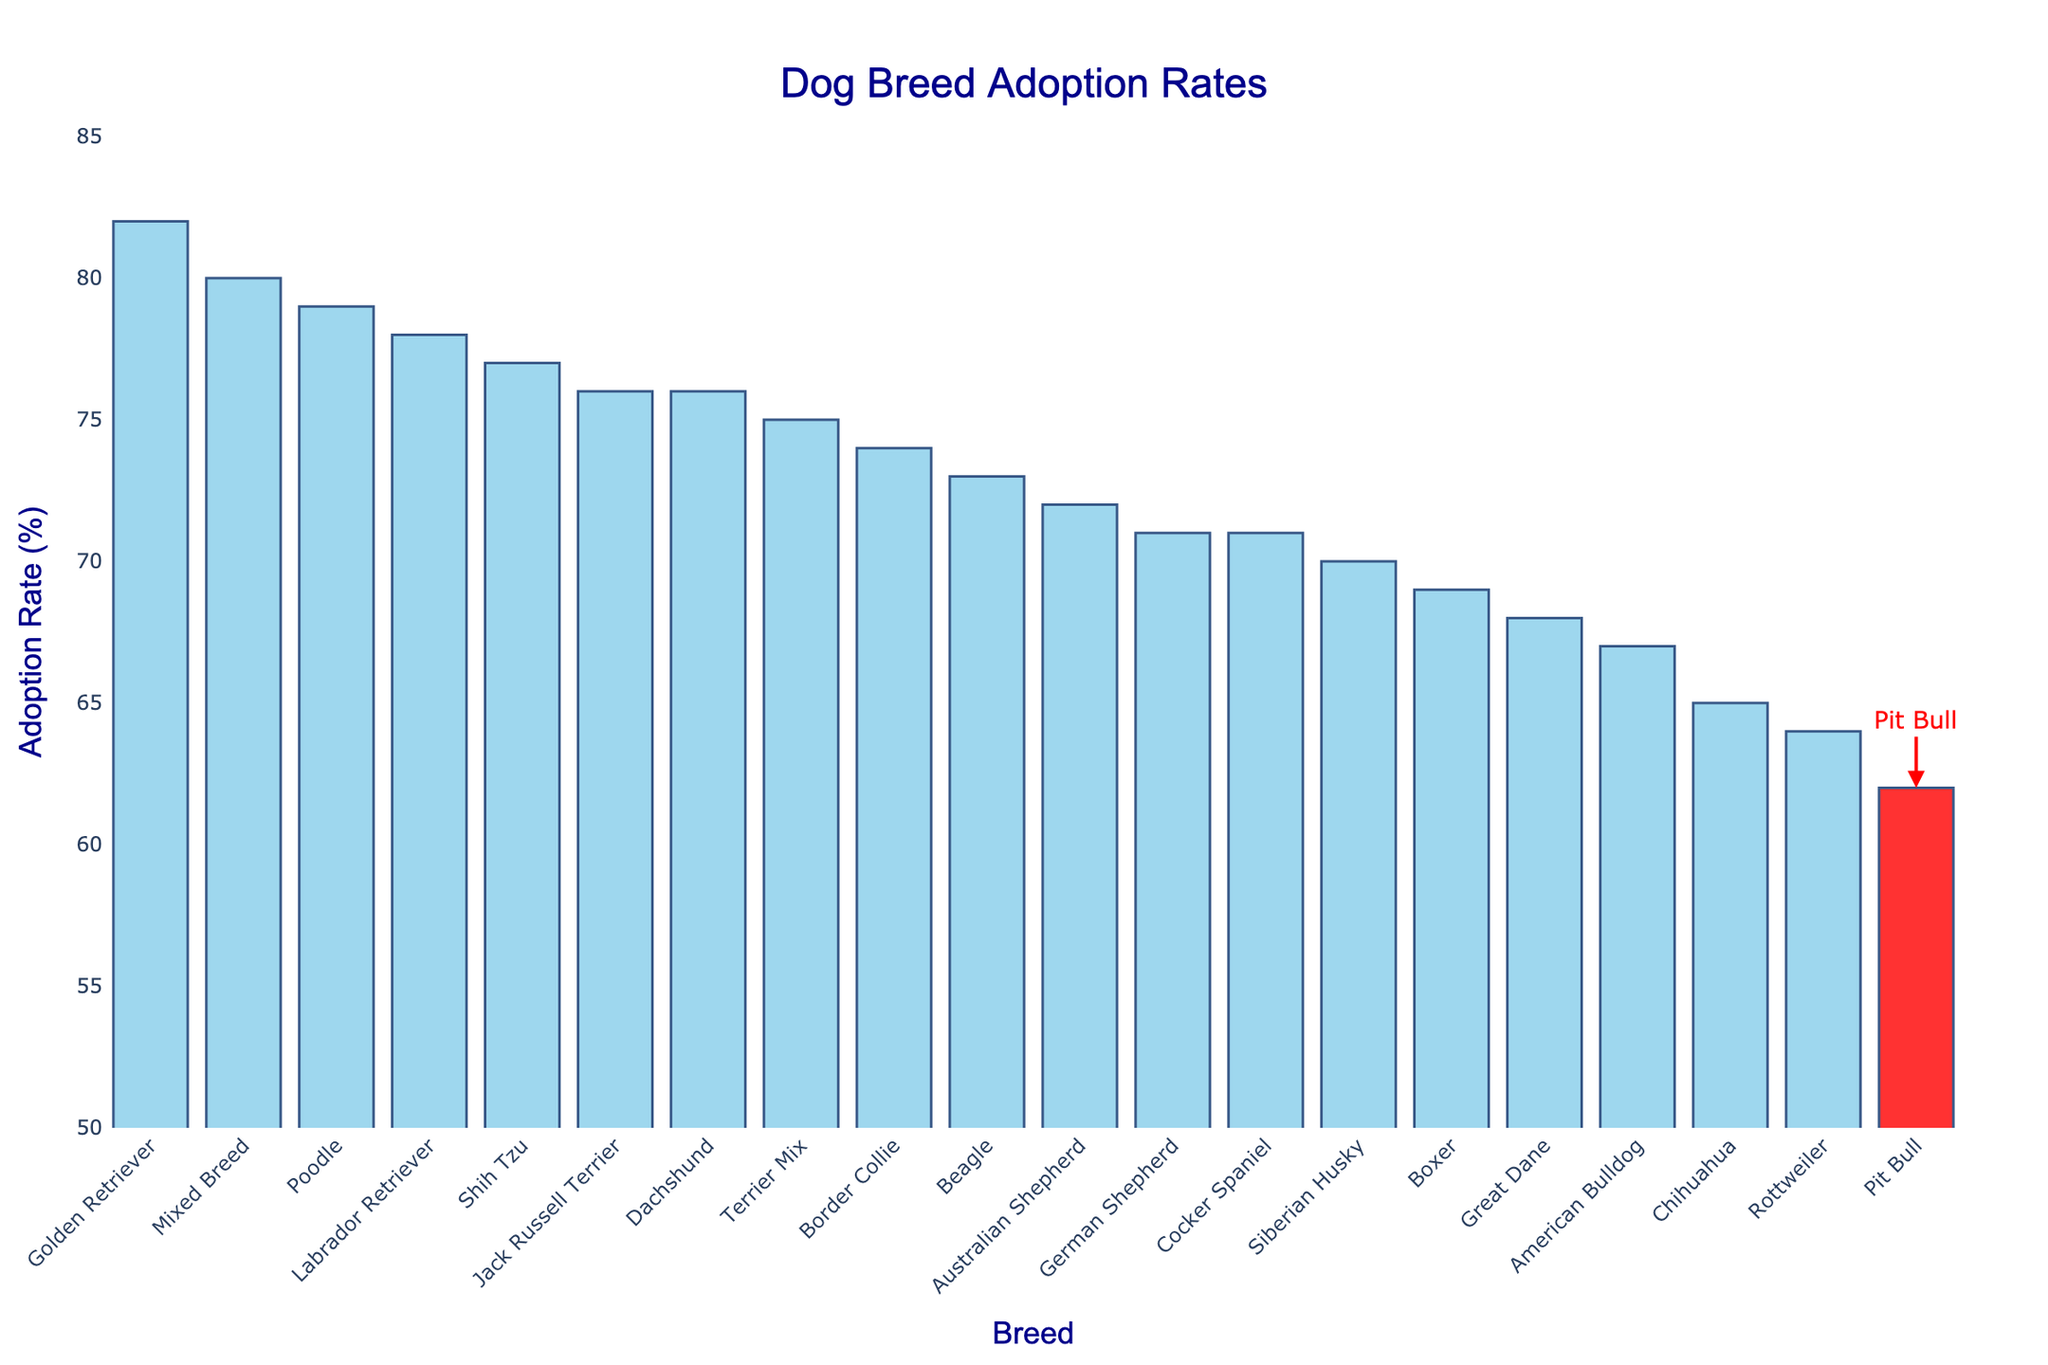What breed has the highest adoption rate? The bar chart shows all the dog breeds ranked by their adoption rates. The breed with the highest bar is "Golden Retriever" with an 82% adoption rate.
Answer: Golden Retriever How does the adoption rate of Pit Bulls compare to that of Labrador Retrievers? The bar for Labrador Retrievers is higher than the bar for Pit Bulls. By counting the adoption rates from the labels, Labrador Retrievers have a 78% rate, while Pit Bulls have a 62% rate. Therefore, Labrador Retrievers have a higher adoption rate.
Answer: Labrador Retrievers have a higher adoption rate Which breed has the lowest adoption rate, and what is it? By looking at the shortest bar, the breed with the lowest adoption rate is Pit Bull, which has an adoption rate of 62%.
Answer: Pit Bull, 62% What's the range of adoption rates among all breeds displayed? To determine the range, we subtract the smallest adoption rate from the largest. The highest rate is 82% (Golden Retriever), and the lowest is 62% (Pit Bull). Thus, the range is 82% - 62% = 20%.
Answer: 20% Which breeds have an adoption rate higher than Pit Bulls but less than 70%? Pit Bulls have an adoption rate of 62%. Looking for bars higher than 62% but less than 70%, we find American Bulldog (67%), Chihuahua (65%), and Rottweiler (64%).
Answer: American Bulldog, Chihuahua, Rottweiler How many breeds have an adoption rate of 70% or higher? Counting the bars with labels that show 70% or higher rates, we see Labrador Retriever, German Shepherd, Beagle, Dachshund, Shih Tzu, and Jack Russell Terrier on top of 4 breeds with rates ranging from 71% and higher. This gives us 10 breeds in total.
Answer: 13 What's the average adoption rate of all the breeds shown on the chart? Sum the adoption rates and divide by the number of breeds. Adding up the rates: 62 + 78 + 71 + 65 + 80 + 69 + 73 + 76 + 70 + 82 + 67 + 75 + 64 + 79 + 72 + 77 + 74 + 68 + 71 + 76 = 1313. Divide by the number of breeds (20), average is 1313/20 = 65.65%.
Answer: 65.65% Which breed has an adoption rate that is only 3% higher than Pit Bulls? Pit Bulls have an adoption rate of 62%. The breed with a rate of 65% (62% + 3%) is Chihuahua.
Answer: Chihuahua Which breeds have an adoption rate of at least 75% but less than 80%? Looking for bars with labels between 75% and 80%, we find Shih Tzu (77%), Jack Russell Terrier (76%), and Terrier Mix (75%).
Answer: Shih Tzu, Jack Russell Terrier, Terrier Mix 